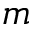<formula> <loc_0><loc_0><loc_500><loc_500>m</formula> 